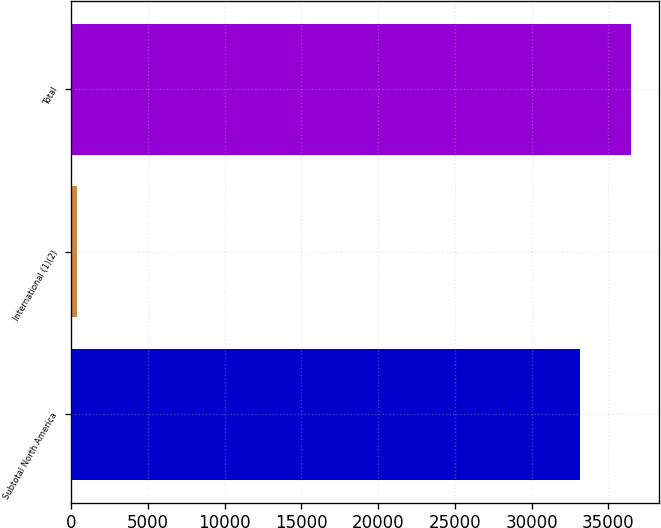Convert chart. <chart><loc_0><loc_0><loc_500><loc_500><bar_chart><fcel>Subtotal North America<fcel>International (1)(2)<fcel>Total<nl><fcel>33171<fcel>377<fcel>36488.1<nl></chart> 